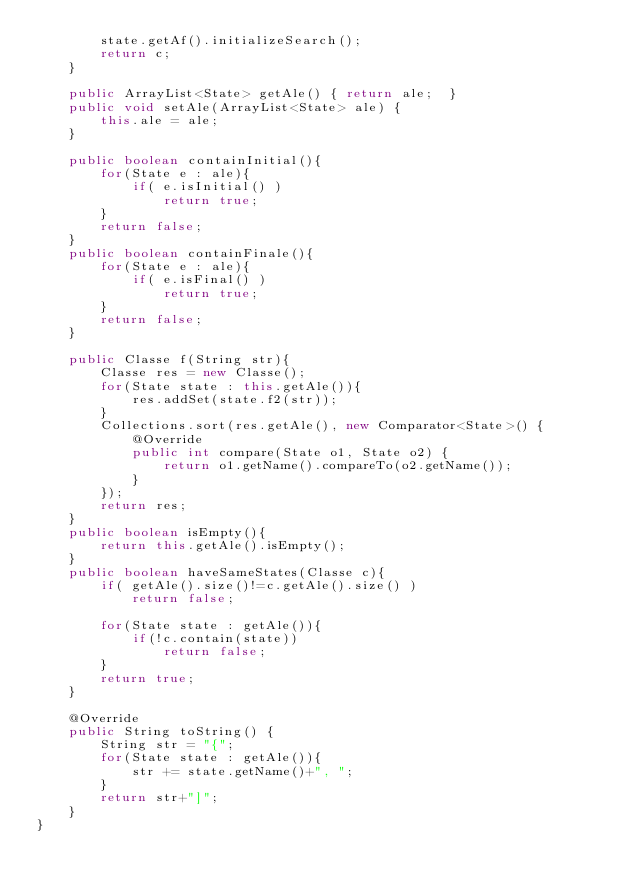Convert code to text. <code><loc_0><loc_0><loc_500><loc_500><_Java_>        state.getAf().initializeSearch();
        return c;
    }

    public ArrayList<State> getAle() { return ale;  }
    public void setAle(ArrayList<State> ale) {
        this.ale = ale;
    }

    public boolean containInitial(){
        for(State e : ale){
            if( e.isInitial() )
                return true;
        }
        return false;
    }
    public boolean containFinale(){
        for(State e : ale){
            if( e.isFinal() )
                return true;
        }
        return false;
    }

    public Classe f(String str){
        Classe res = new Classe();
        for(State state : this.getAle()){
            res.addSet(state.f2(str));
        }
        Collections.sort(res.getAle(), new Comparator<State>() {
            @Override
            public int compare(State o1, State o2) {
                return o1.getName().compareTo(o2.getName());
            }
        });
        return res;
    }
    public boolean isEmpty(){
        return this.getAle().isEmpty();
    }
    public boolean haveSameStates(Classe c){
        if( getAle().size()!=c.getAle().size() )
            return false;

        for(State state : getAle()){
            if(!c.contain(state))
                return false;
        }
        return true;
    }

    @Override
    public String toString() {
        String str = "{";
        for(State state : getAle()){
            str += state.getName()+", ";
        }
        return str+"]";
    }
}
</code> 